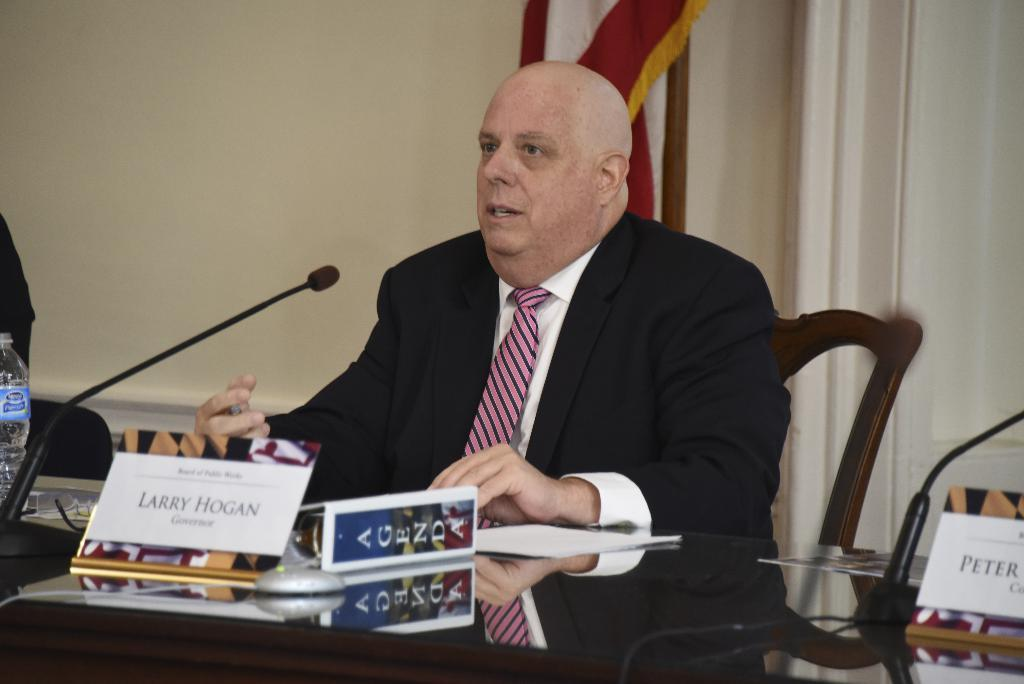Who is present in the image? There is a man in the image. What is the man doing in the image? The man is seated on a chair. What objects are on the table in the image? There is a water bottle and a microphone on the table. What type of pencil is the man using to write on the paper in the image? There is no paper or pencil present in the image. 